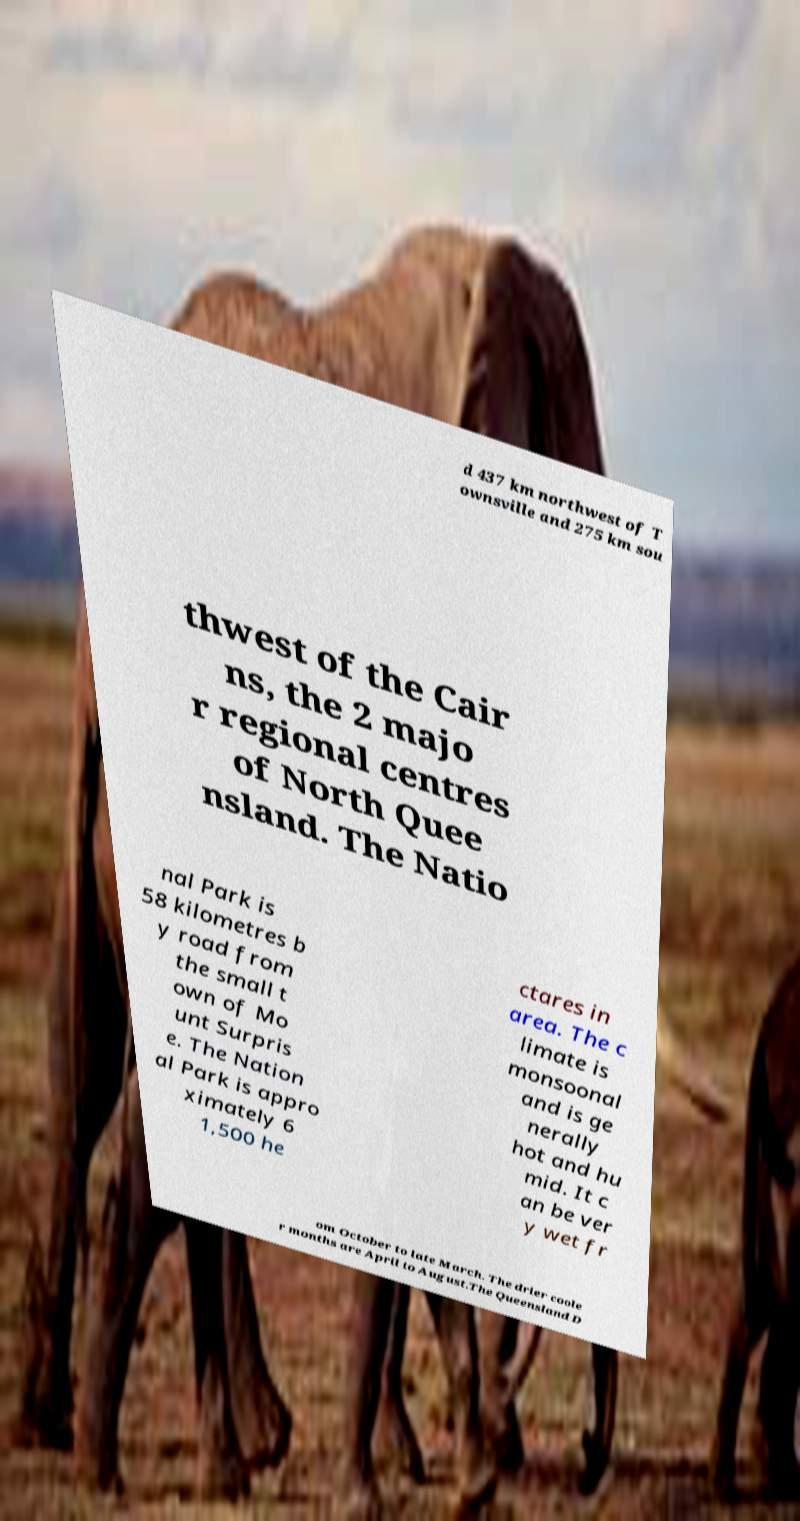What messages or text are displayed in this image? I need them in a readable, typed format. d 437 km northwest of T ownsville and 275 km sou thwest of the Cair ns, the 2 majo r regional centres of North Quee nsland. The Natio nal Park is 58 kilometres b y road from the small t own of Mo unt Surpris e. The Nation al Park is appro ximately 6 1,500 he ctares in area. The c limate is monsoonal and is ge nerally hot and hu mid. It c an be ver y wet fr om October to late March. The drier coole r months are April to August.The Queensland D 